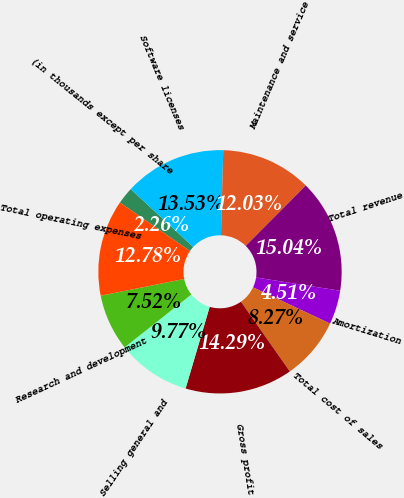Convert chart. <chart><loc_0><loc_0><loc_500><loc_500><pie_chart><fcel>(in thousands except per share<fcel>Software licenses<fcel>Maintenance and service<fcel>Total revenue<fcel>Amortization<fcel>Total cost of sales<fcel>Gross profit<fcel>Selling general and<fcel>Research and development<fcel>Total operating expenses<nl><fcel>2.26%<fcel>13.53%<fcel>12.03%<fcel>15.04%<fcel>4.51%<fcel>8.27%<fcel>14.29%<fcel>9.77%<fcel>7.52%<fcel>12.78%<nl></chart> 